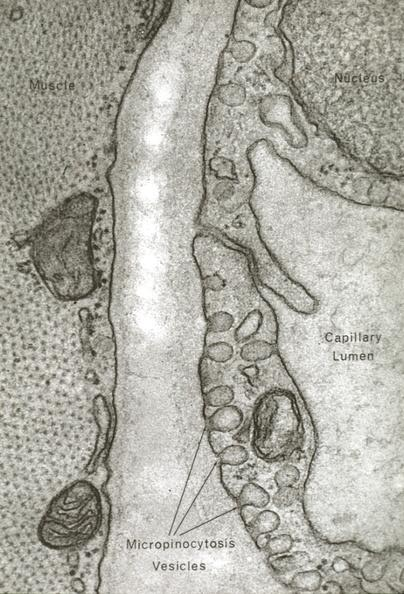s cardiovascular present?
Answer the question using a single word or phrase. Yes 